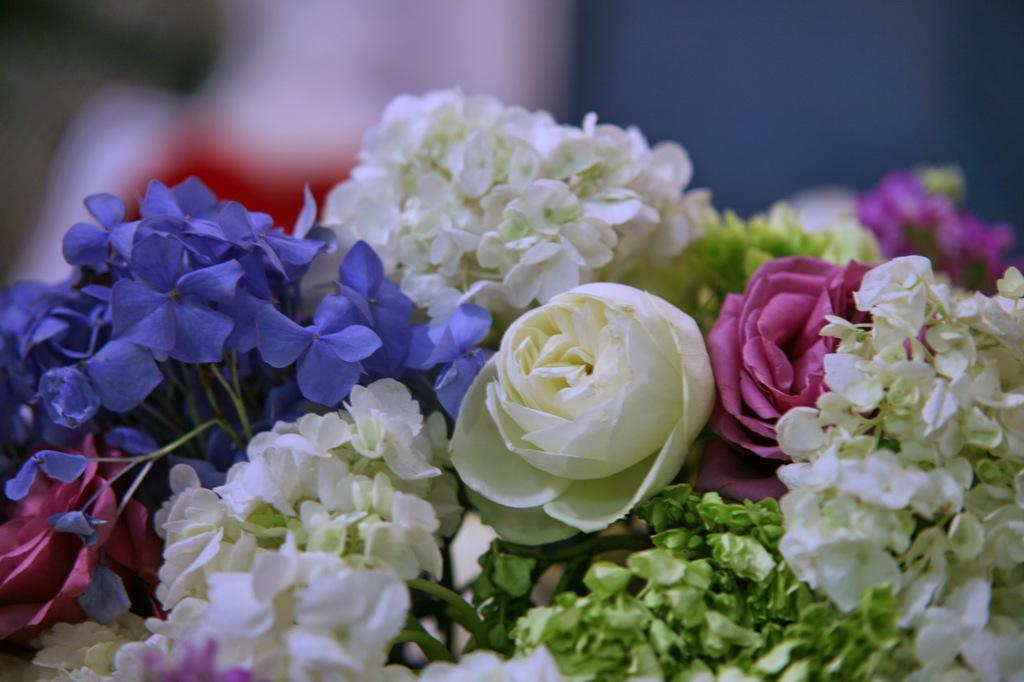What types of plants are present in the image? There are varieties of flowers in the image. Can you describe the background of the image? The backdrop of the image is blurred. What type of faucet is visible in the image? There is no faucet present in the image; it features varieties of flowers with a blurred backdrop. What chess pieces can be seen on the table in the image? There is no table or chess pieces present in the image; it only contains flowers and a blurred backdrop. 